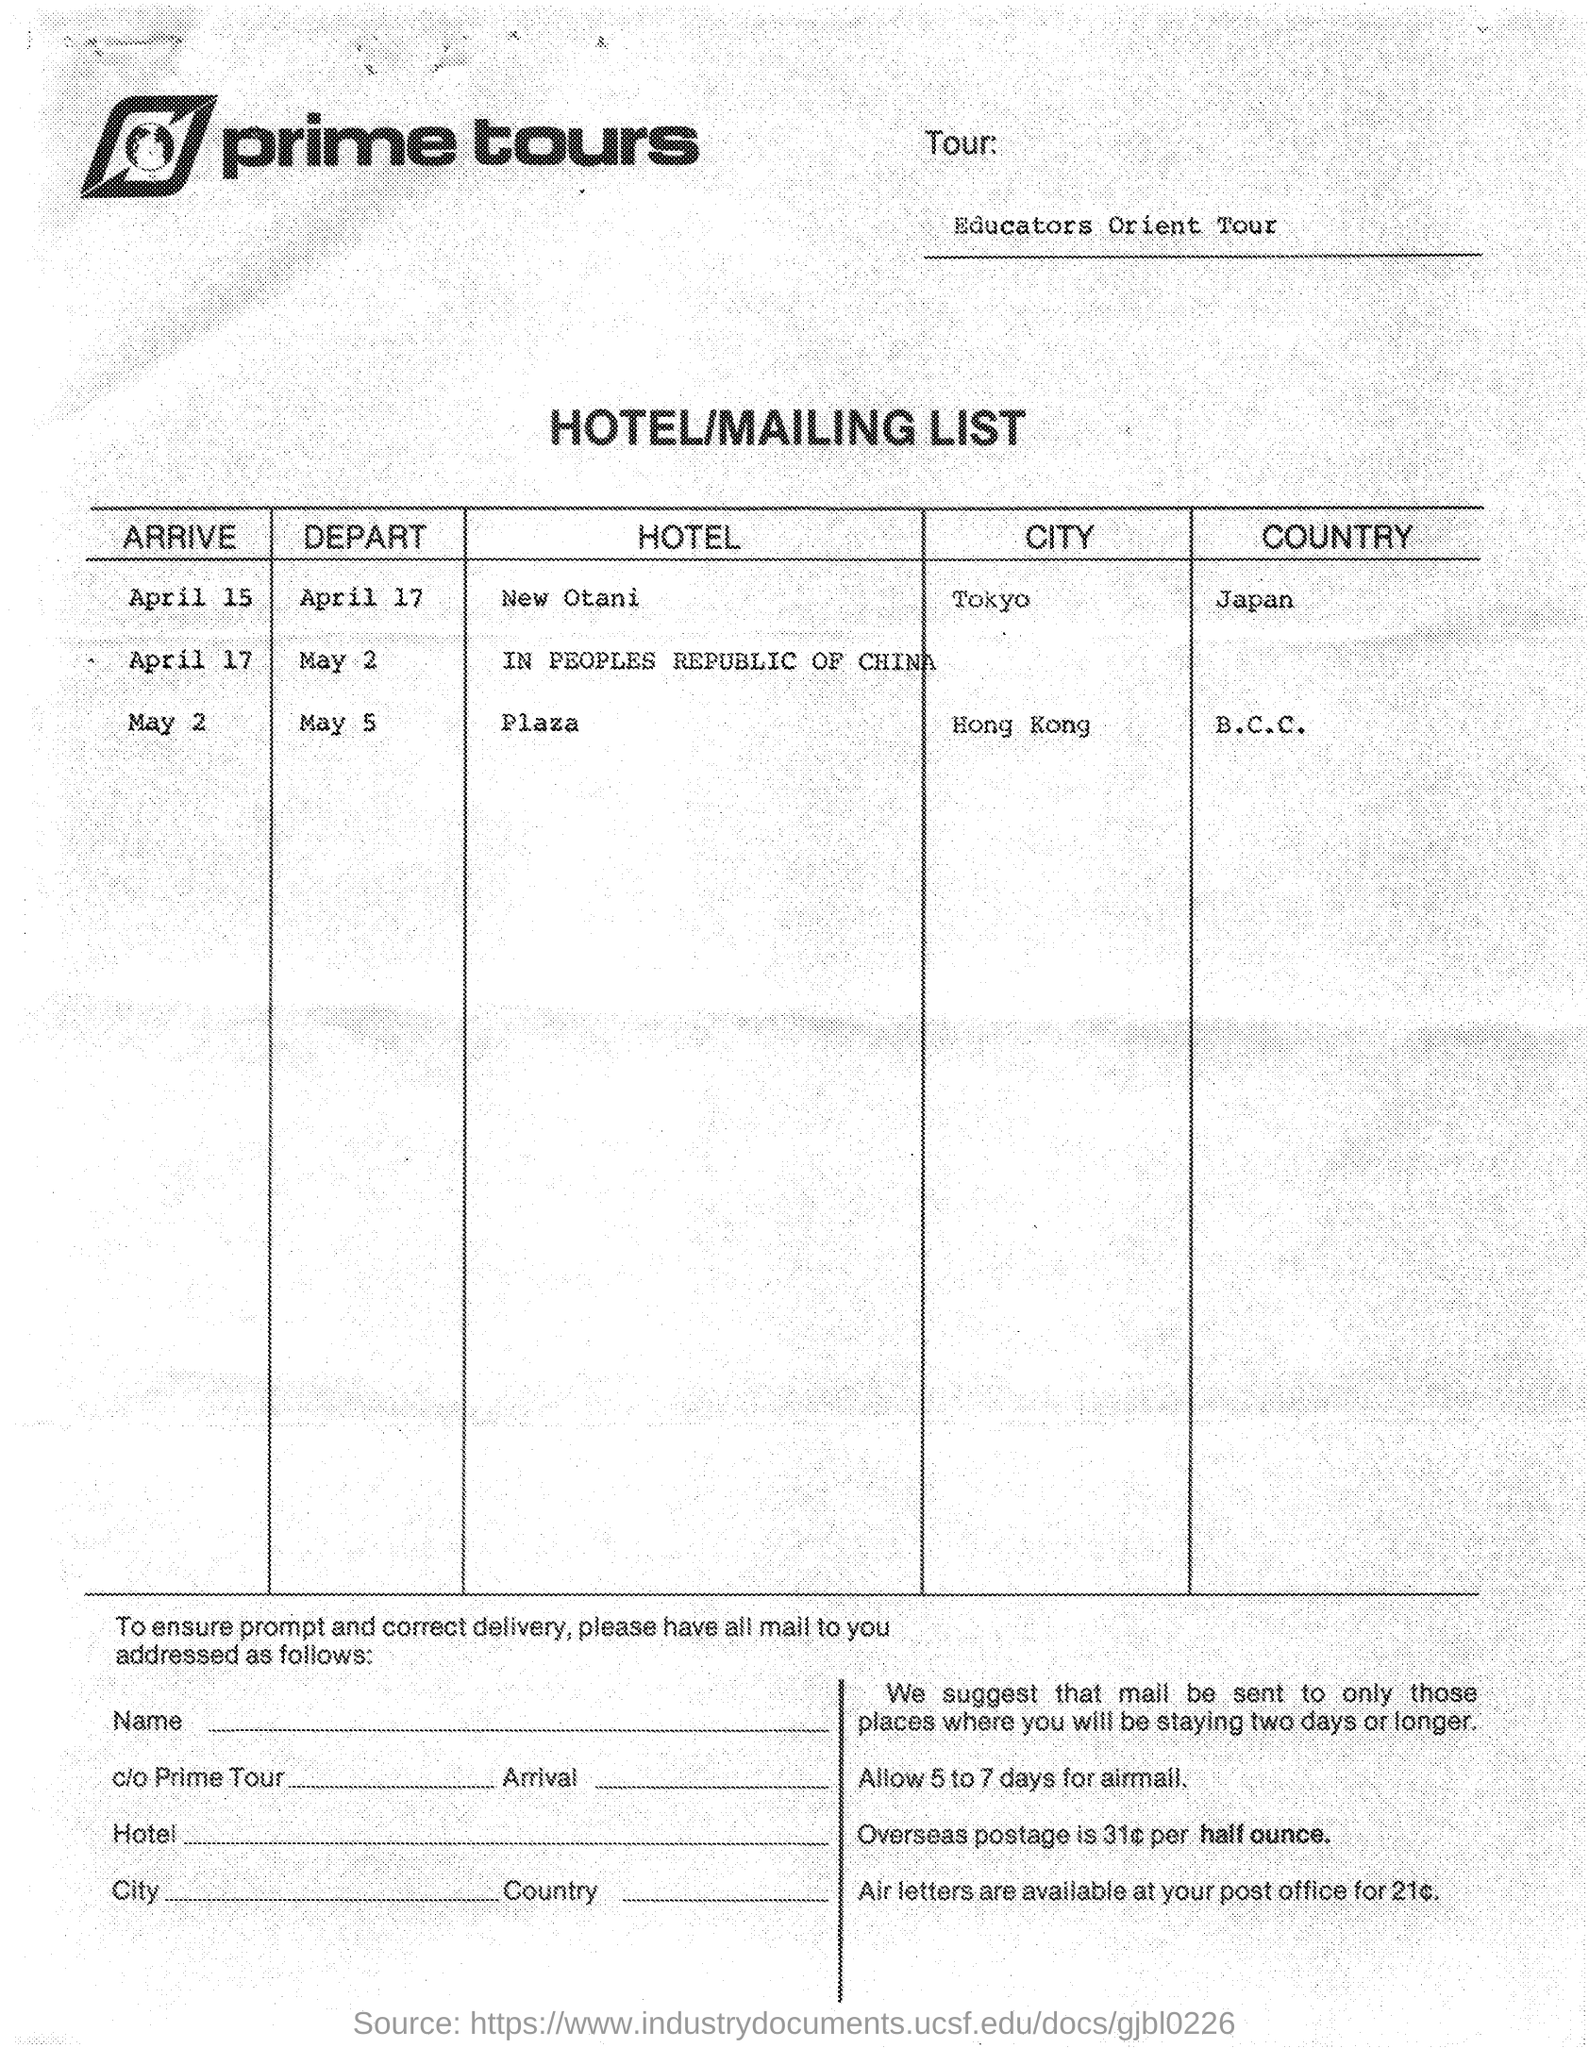Mention a couple of crucial points in this snapshot. The name of the tour company is Prime Tours. The country of Tokyo is Japan. Hong Kong is a country that is located in B.C.C.. 